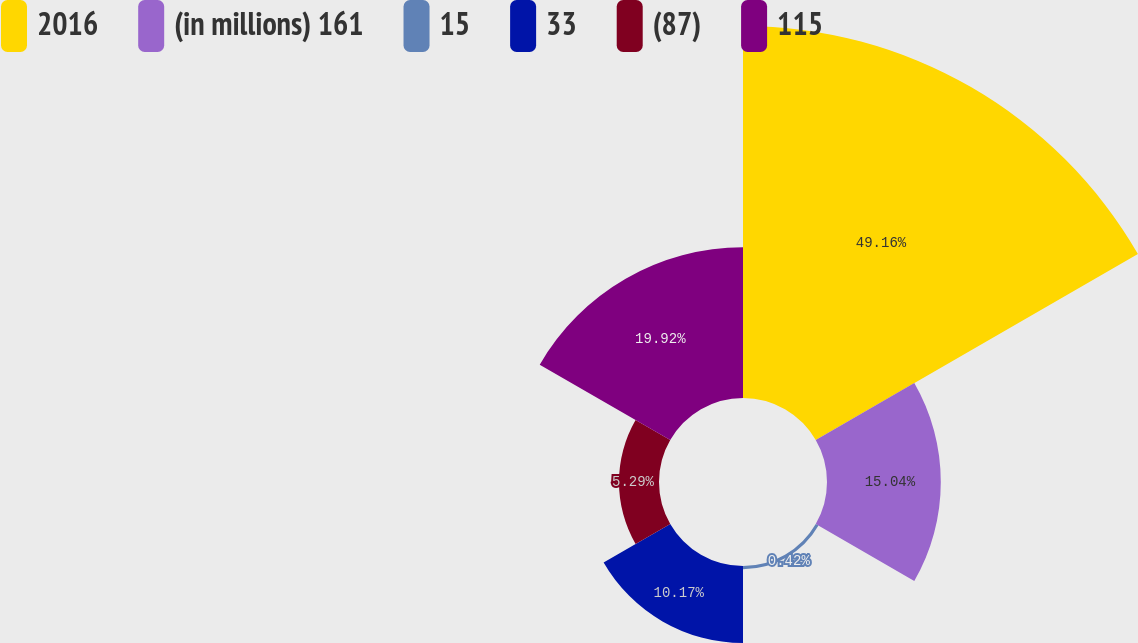Convert chart to OTSL. <chart><loc_0><loc_0><loc_500><loc_500><pie_chart><fcel>2016<fcel>(in millions) 161<fcel>15<fcel>33<fcel>(87)<fcel>115<nl><fcel>49.17%<fcel>15.04%<fcel>0.42%<fcel>10.17%<fcel>5.29%<fcel>19.92%<nl></chart> 